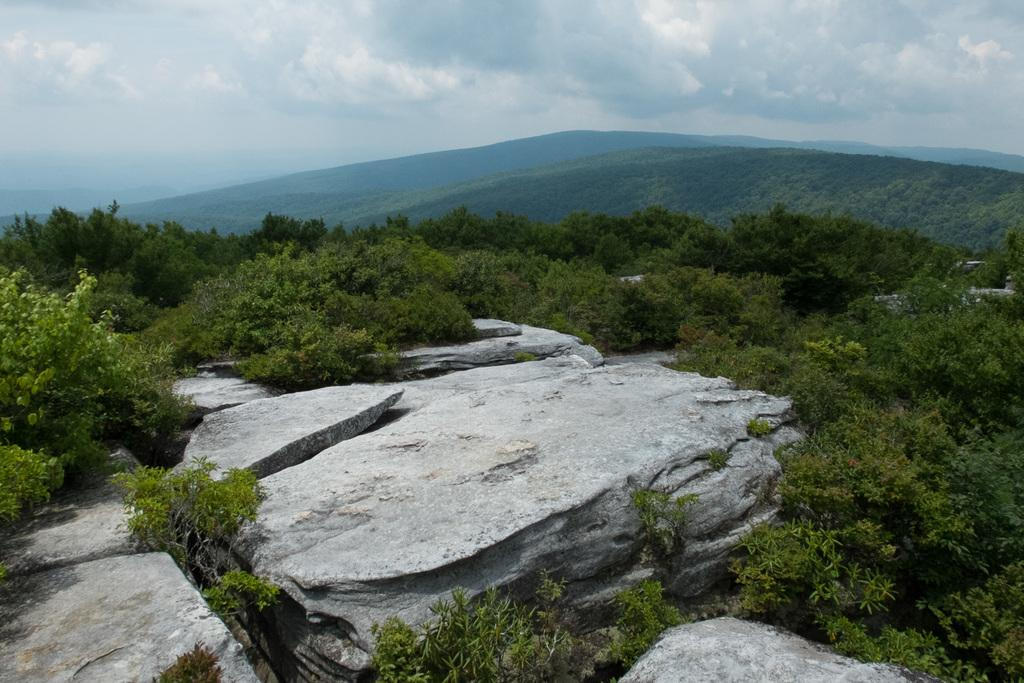What can be seen in the foreground of the image? There are rocks and trees in the foreground of the image. What is visible in the background of the image? There are mountains and the sky in the background of the image. What can be observed in the sky? There are clouds in the sky. What type of noise can be heard coming from the table in the image? There is no table present in the image, and therefore no noise can be heard coming from it. What is the table used for in the image? There is no table present in the image, so it cannot be used for anything. 